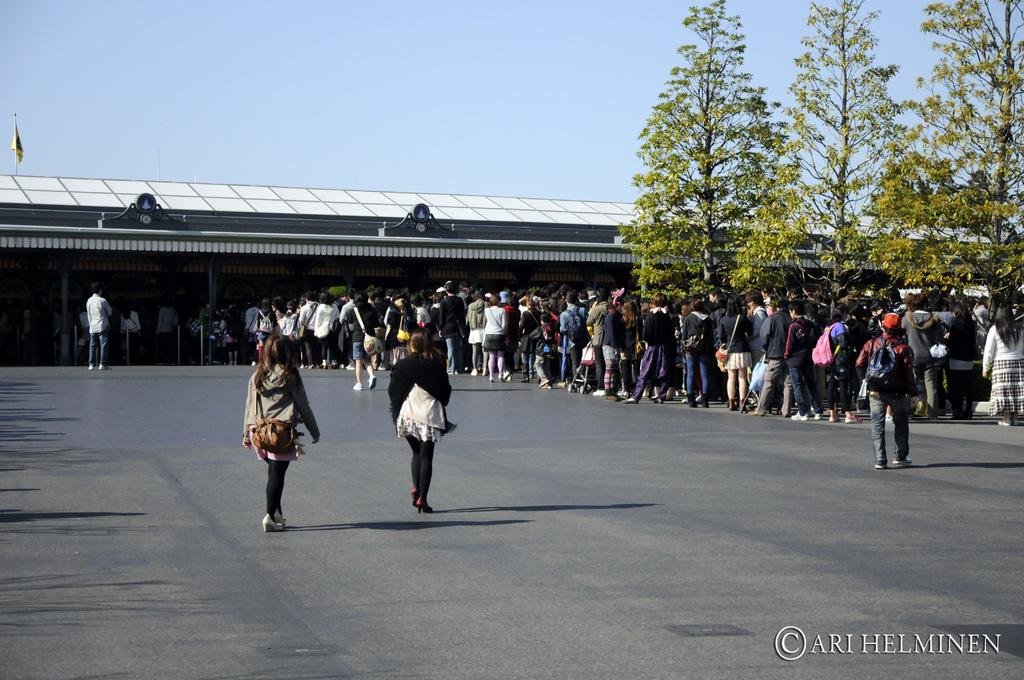What are the people in the image doing? The people in the image are standing in a queue. What can be seen in the right corner of the image? There are trees in the right corner of the image. What is visible in the background of the image? There is a building in the background of the image. Can you see a toad hopping near the trees in the image? There is no toad present in the image. What type of liquid is being served at the event in the image? There is no event or liquid being served in the image; it only shows people standing in a queue and trees in the right corner. 